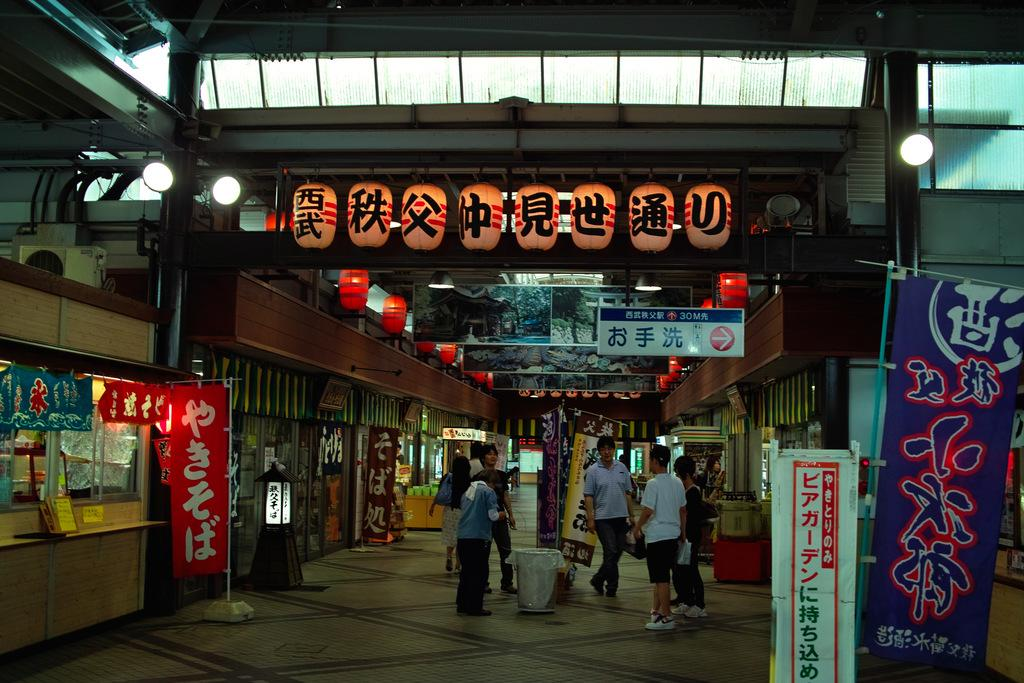How many people are in the group visible in the image? There is a group of people standing in the image, but the exact number cannot be determined from the provided facts. What type of establishments can be seen in the image? There are shops in the image. What are the boards used for in the image? The boards in the image are not described in detail, so their purpose cannot be determined. What type of lighting is present in the image? There are lights in the image, but their specific type or function is not mentioned. What do the banners in the image advertise or promote? The banners in the image are not described in detail, so their purpose or message cannot be determined. What type of decorative objects are present in the image? There are paper lanterns in the image, which are a type of decorative object. What other objects can be seen in the image? There are other objects present in the image, but their specific nature is not mentioned. What type of bone is visible in the image? There is no bone present in the image. What type of cloud is visible in the image? There is no cloud present in the image. 